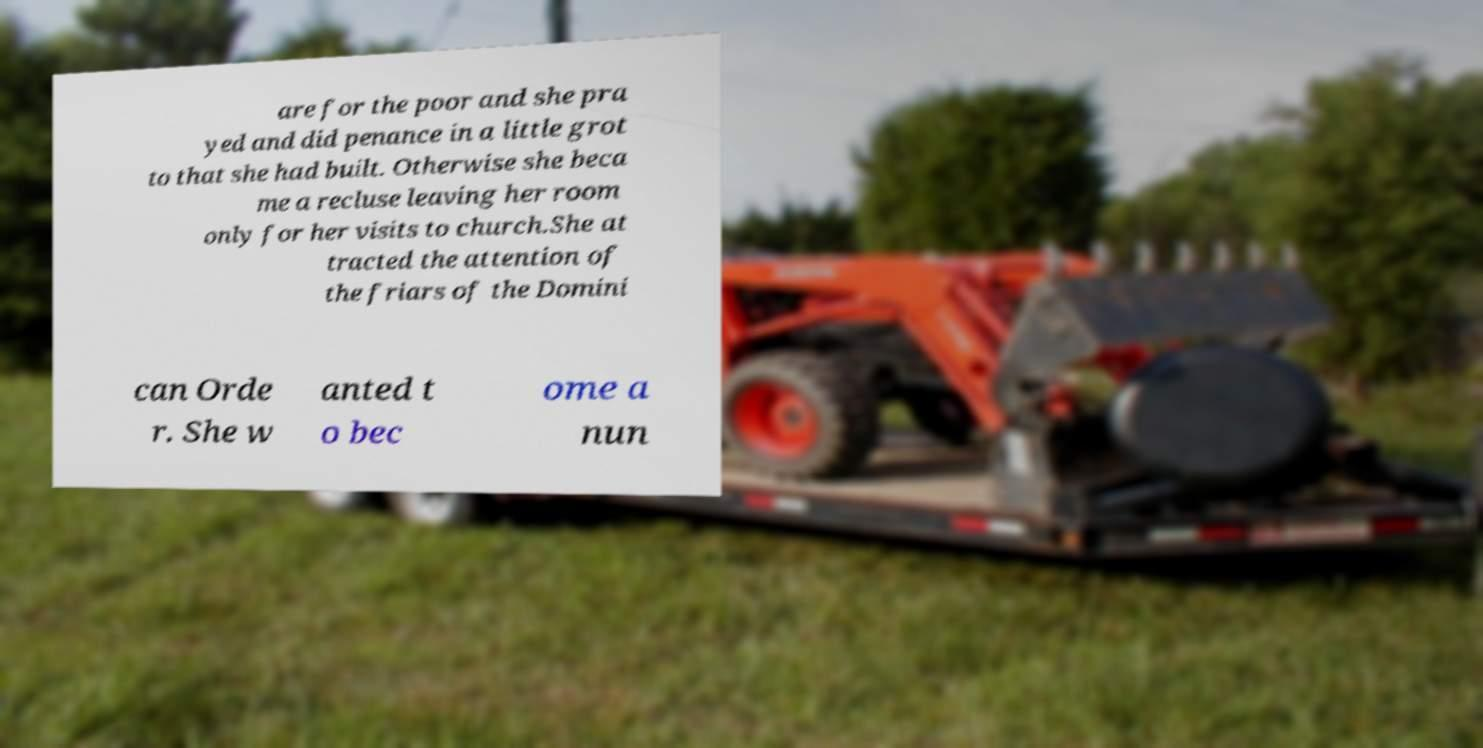What messages or text are displayed in this image? I need them in a readable, typed format. are for the poor and she pra yed and did penance in a little grot to that she had built. Otherwise she beca me a recluse leaving her room only for her visits to church.She at tracted the attention of the friars of the Domini can Orde r. She w anted t o bec ome a nun 